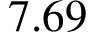Convert formula to latex. <formula><loc_0><loc_0><loc_500><loc_500>7 . 6 9</formula> 